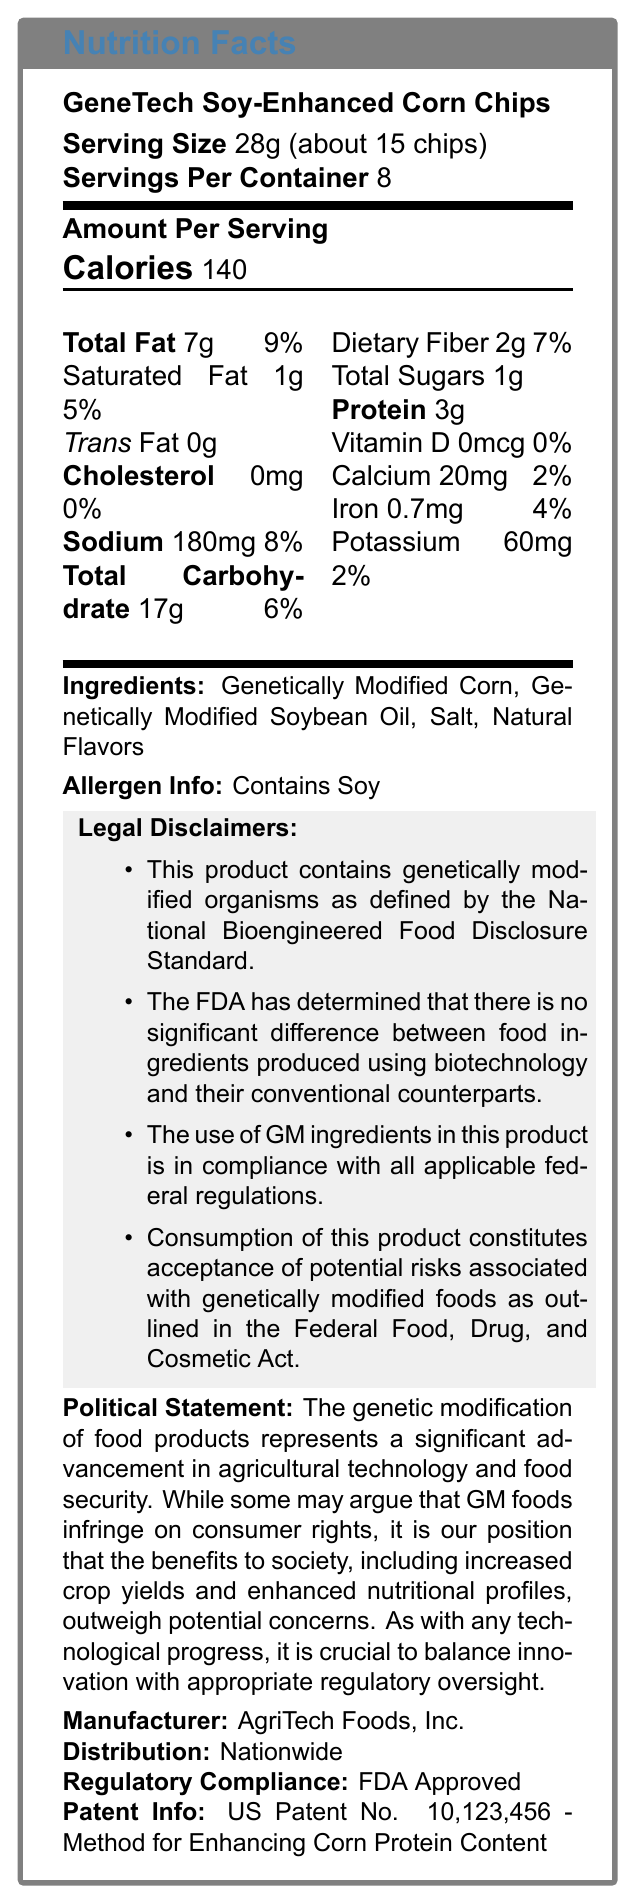What is the serving size of GeneTech Soy-Enhanced Corn Chips? The serving size is specified directly under the product name in the document.
Answer: 28g (about 15 chips) How many calories are in a single serving of GeneTech Soy-Enhanced Corn Chips? The calorie information is prominently displayed under "Amount Per Serving."
Answer: 140 calories What percentage of the daily value for sodium does a single serving contain? The sodium content and its percentage of the daily value are listed under the nutritional information.
Answer: 8% List the primary ingredients in the GeneTech Soy-Enhanced Corn Chips. The ingredients are listed after the nutritional details.
Answer: Genetically Modified Corn, Genetically Modified Soybean Oil, Salt, Natural Flavors Does the product contain any allergenic ingredients? It is stated in the allergen information section that the product contains soy.
Answer: Yes According to the document, how much dietary fiber is in one serving? The amount of dietary fiber per serving is listed under the carbohydrate section.
Answer: 2g Which statement is correct regarding the presence of GMOs in this product? 
A. The product is GMO-free 
B. The product contains genetically modified organisms 
C. The product contains only natural ingredients 
D. The product's GMO status is not disclosed The product contains genetically modified organisms as stated under legal disclaimers.
Answer: B What is the manufacturer's name? 
1. AgriTech Foods, Inc. 
2. BioFood Corp. 
3. GreenEarth Produce 
4. NutriKnowledge Ltd. The manufacturer is listed as AgriTech Foods, Inc.
Answer: 1 Is the product distribution limited to a specific region? The document states "Distribution: Nationwide," implying it is available nationwide.
Answer: No Summarize the key information presented in the document. This summary is based on scanning the entire content of the document.
Answer: The document provides nutritional information for GeneTech Soy-Enhanced Corn Chips, detailing serving size, calories, and nutritional content per serving. It includes a list of ingredients, allergen information, and various legal disclaimers related to GMOs. Additionally, a political statement in favor of GMOs is presented, along with manufacturer, distribution, regulatory compliance, and patent information. What is the vitamin D content per serving of the product? The vitamin D content is clearly listed in the nutritional information.
Answer: 0mcg Who has determined there is no significant difference between food ingredients produced using biotechnology and their conventional counterparts? This statement is found under the legal disclaimers section.
Answer: The FDA What federal regulation framework does the document mention regarding potential risks associated with genetically modified foods? This piece of legal information is included in one of the legal disclaimers.
Answer: The Federal Food, Drug, and Cosmetic Act How does the political statement characterize the genetic modification of food products? This is stated in the "Political Statement" section.
Answer: As a significant advancement in agricultural technology and food security What is the total amount of protein per serving? The protein amount per serving is listed under the nutritional facts.
Answer: 3g Is there any information about the environmental impact of genetically modified ingredients in the document? The document does not provide details on the environmental impact of genetically modified ingredients.
Answer: Not enough information 